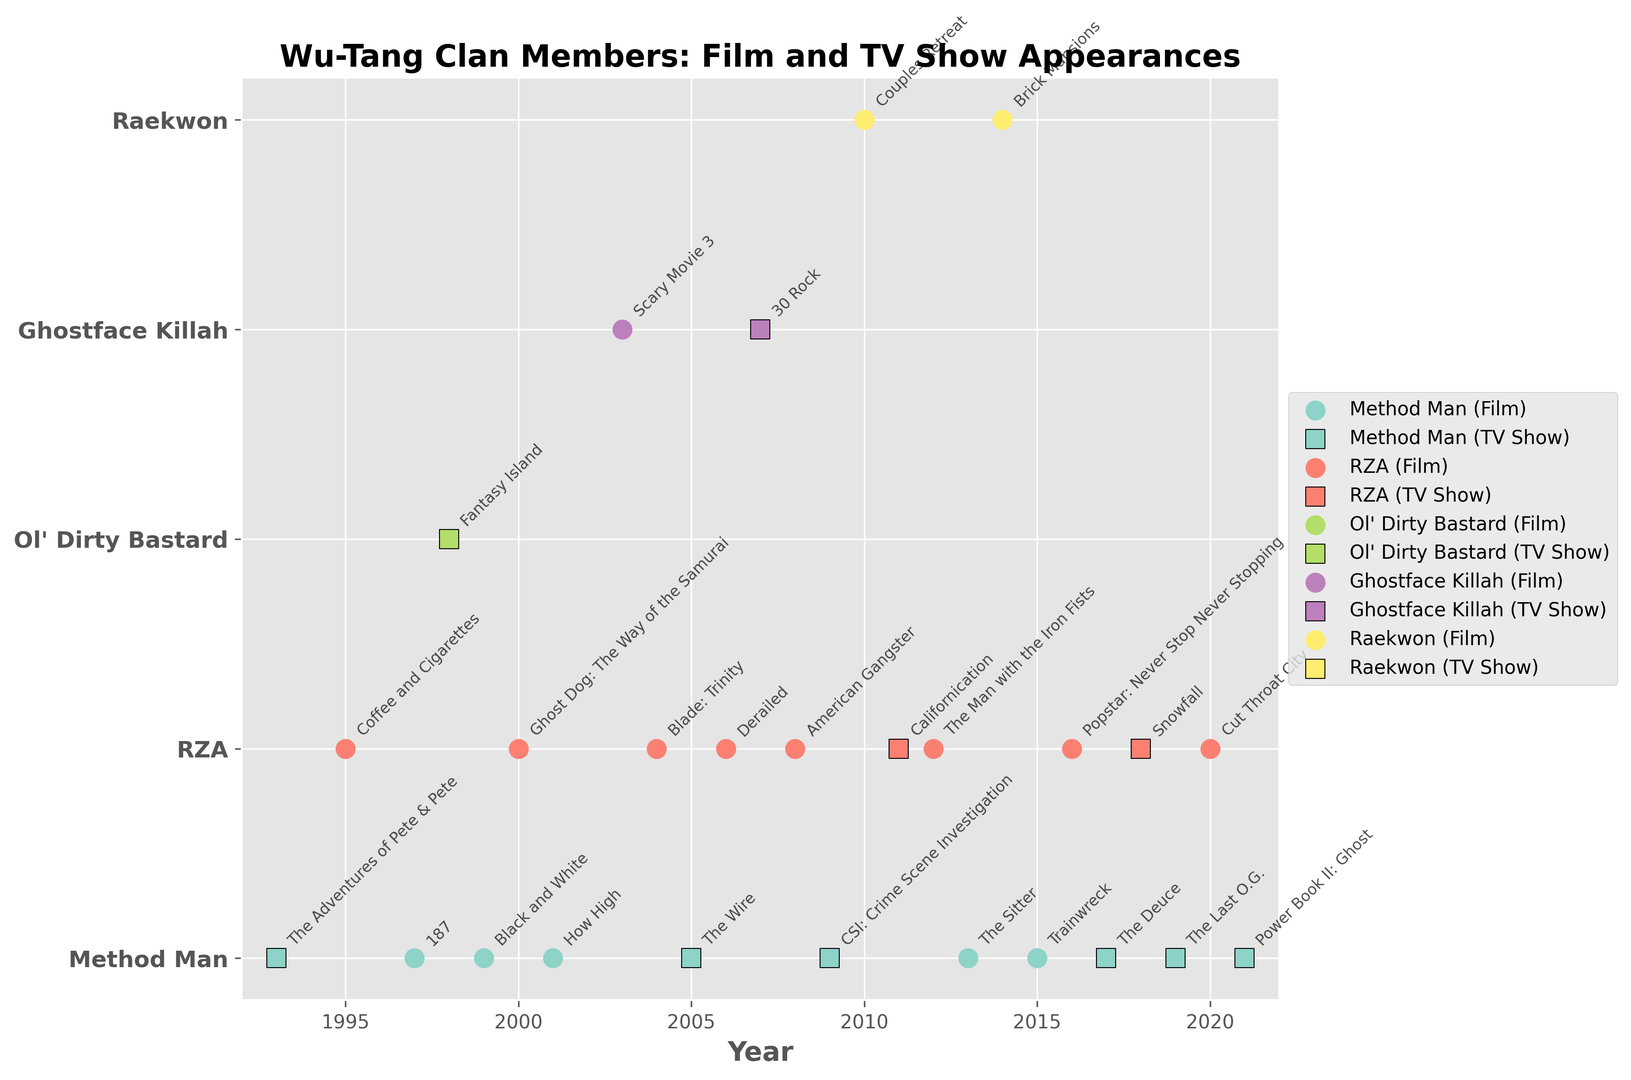When did Method Man first appear in a film? Method Man appeared in "187" in 1997 as per the data in the figure where each appearance is annotated.
Answer: 1997 Which member has the most appearances in TV shows? By counting the scatter points for each member delineated by the square markers representing TV shows, Method Man has the most, with appearances in "The Adventures of Pete & Pete" (1993), "The Wire" (2005), "CSI: Crime Scene Investigation" (2009), "The Deuce" (2017), "The Last O.G." (2019), and "Power Book II: Ghost" (2021).
Answer: Method Man Who appeared in both TV and Film formats, and in what years did they overlap? Method Man and RZA both have appearances in both formats. Method Man had TV appearances in 1993, 2005, 2009, 2017, 2019, and 2021, and film appearances in 1997, 1999, 2001, 2013, 2015. RZA's TV appearances were in 2011 and 2018, and his film appearances were in 1995, 2000, 2004, 2006, 2008, 2012, 2016, and 2020. There are no overlapping years for Method Man but RZA appeared in both TV and Film in 2011.
Answer: Method Man: none, RZA: 2011 Which member has collaborated the most with TV shows according to the timeline? By counting individual appearances, Method Man appears in TV shows the most frequently (6 times).
Answer: Method Man Compare RZA’s and Method Man's appearances from the 2000s to the 2010s. Who appeared more frequently and in what formats? RZA appeared in films in 2000, 2004, 2006, 2008, 2012, 2016, and 2020, and TV shows in 2011 and 2018. Method Man appeared in films in 2001, 2013, and 2015, and TV shows in 2005, 2009, 2017, 2019, and 2021. So, in the 2000s, RZA appeared 4 times and Method Man 3 times, and in the 2010s, RZA appeared 4 times while Method Man appeared 5 times. Method Man thus has more appearances overall and especially in TV in the 2010s.
Answer: Method Man, mostly in TV shows 